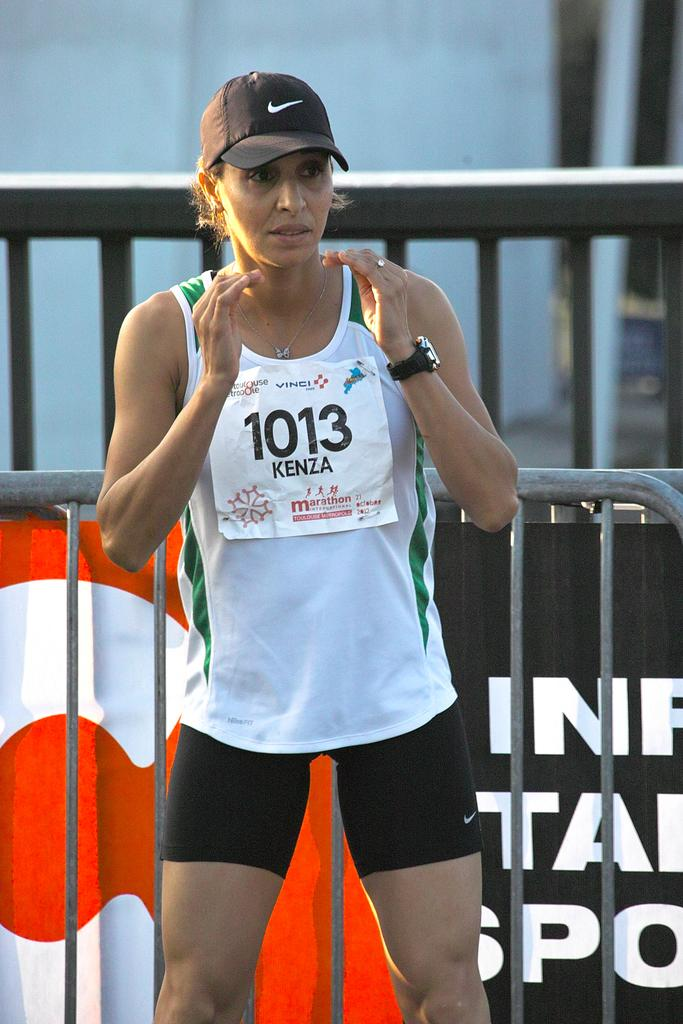<image>
Create a compact narrative representing the image presented. A lady in sports attire with the number 1013 on her shirt. 